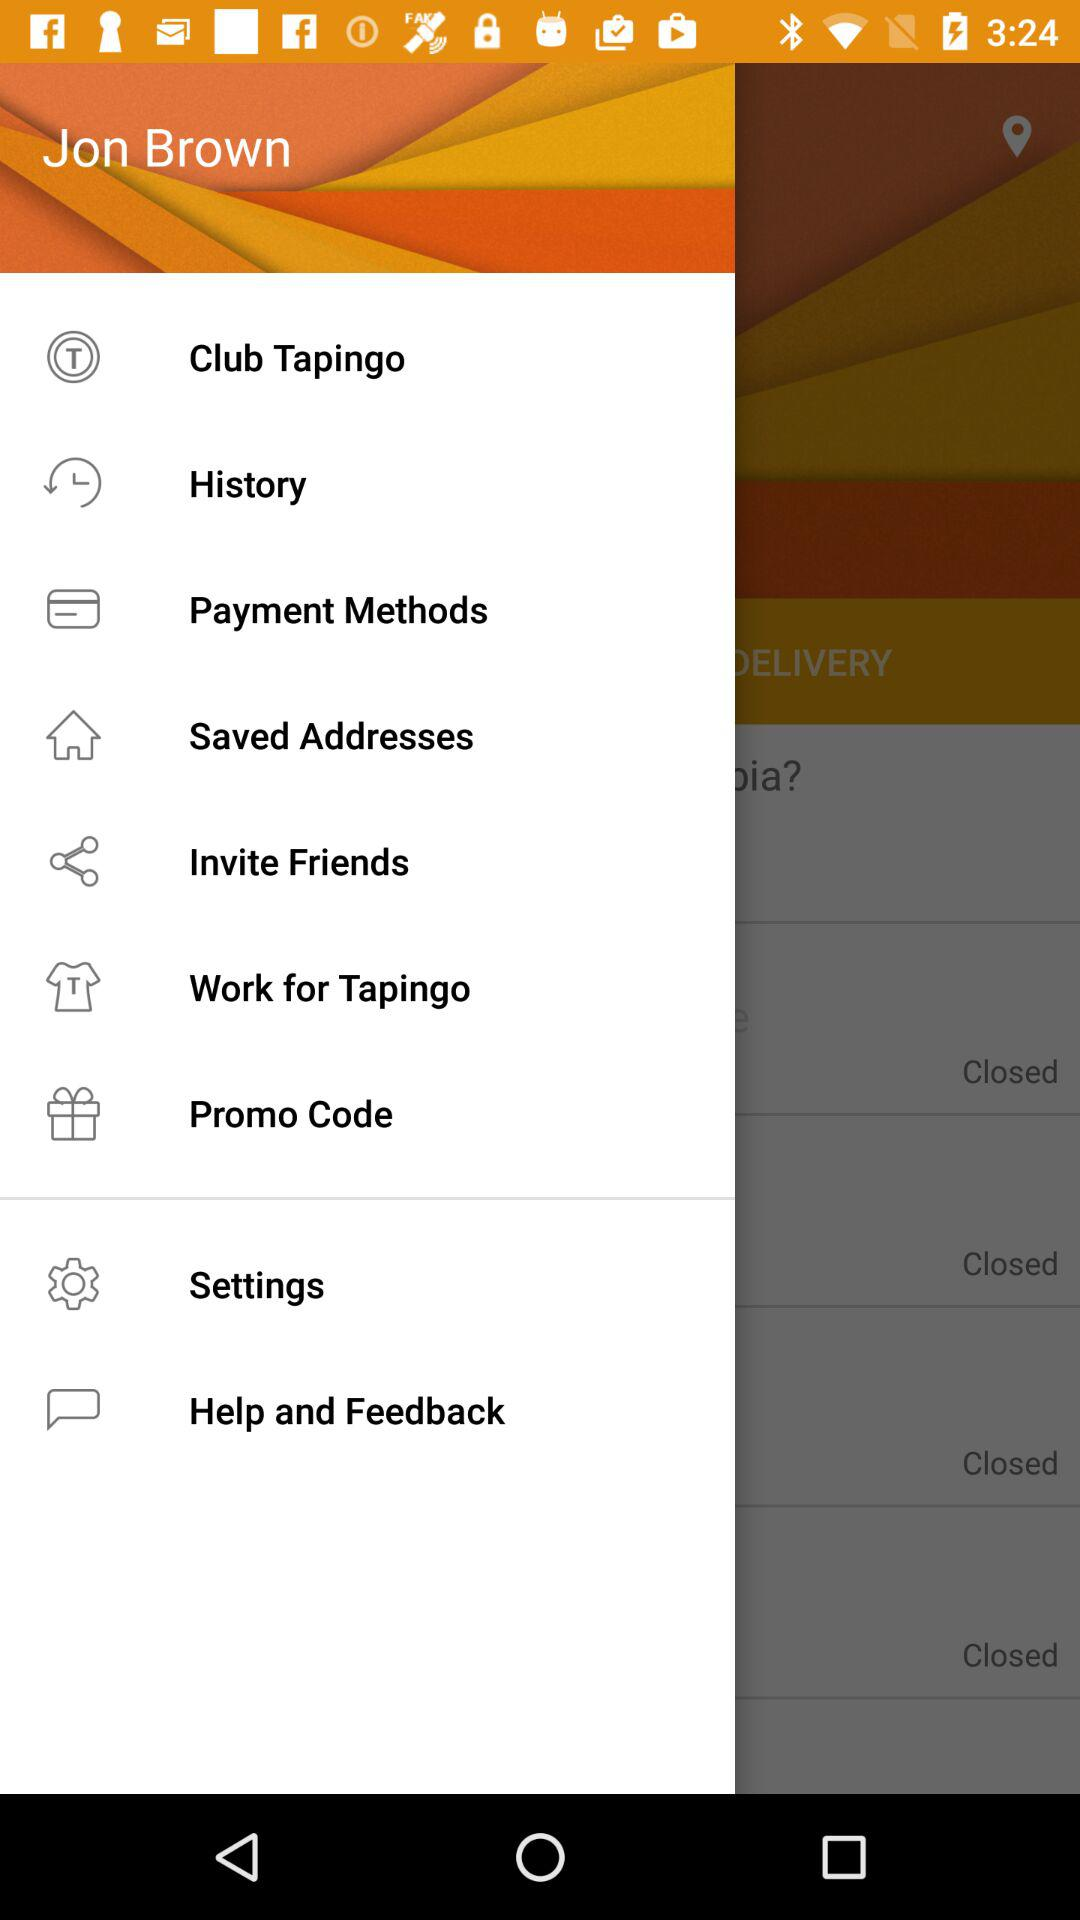What is the user's name? The user's name is Jon Brown. 